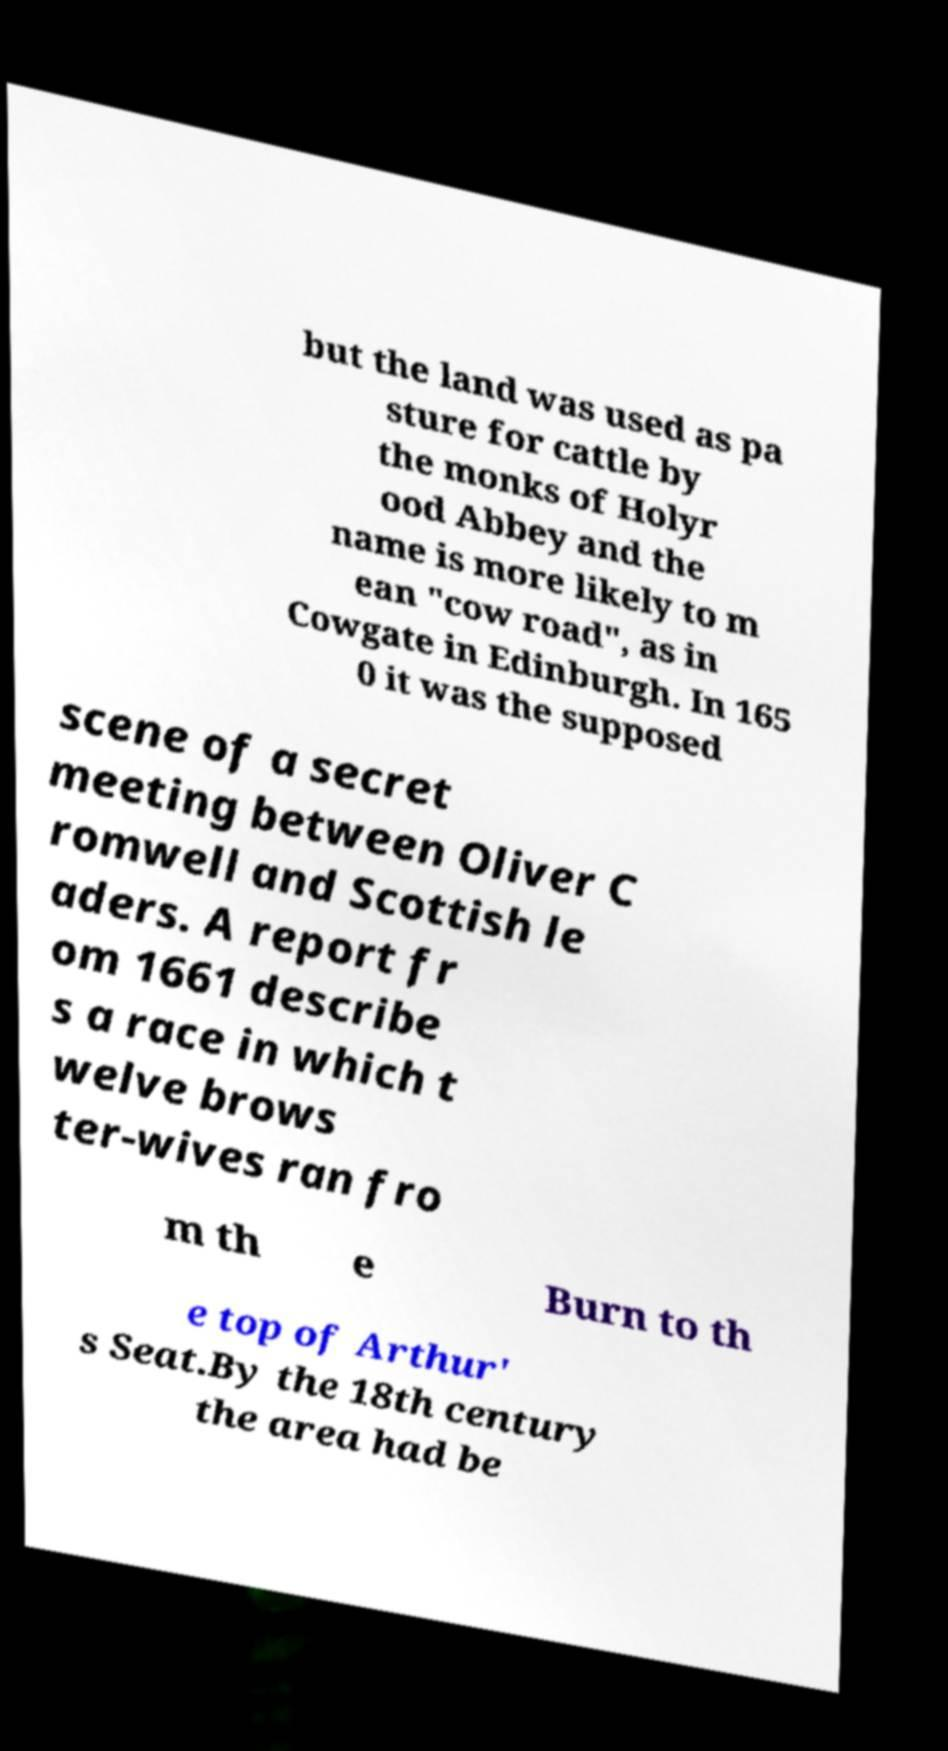Could you extract and type out the text from this image? but the land was used as pa sture for cattle by the monks of Holyr ood Abbey and the name is more likely to m ean "cow road", as in Cowgate in Edinburgh. In 165 0 it was the supposed scene of a secret meeting between Oliver C romwell and Scottish le aders. A report fr om 1661 describe s a race in which t welve brows ter-wives ran fro m th e Burn to th e top of Arthur' s Seat.By the 18th century the area had be 